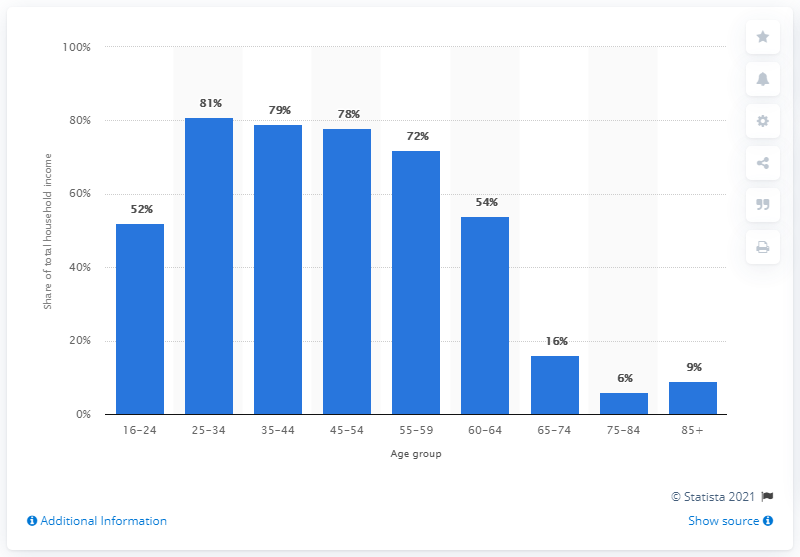Indicate a few pertinent items in this graphic. In the 2017/18 fiscal year, approximately 79% of household income was financed by wages and salaries. 